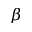<formula> <loc_0><loc_0><loc_500><loc_500>\beta</formula> 